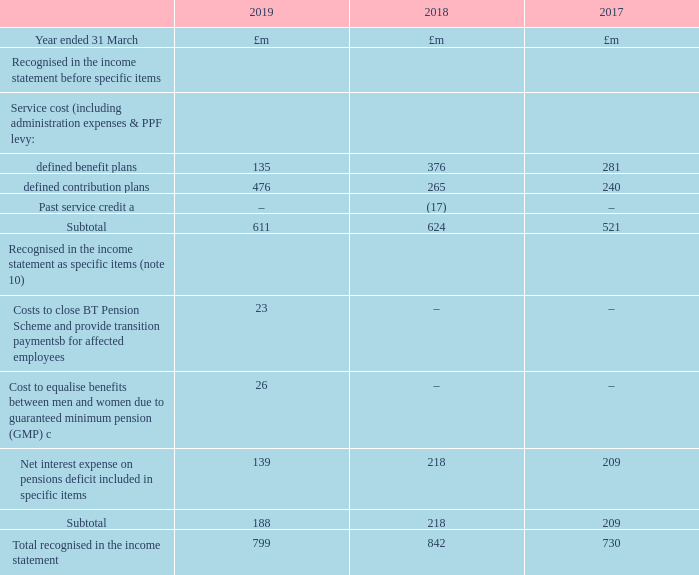Amounts in the financial statements Group income statement
The expense or income arising from all group retirement benefit arrangements recognised in the group income statement is shown below.
a Relates to the removal of future indexation obligations following changes to the benefits provided under certain pension plans operating outside the UK in 2017/18. b All employees impacted by the closure of the BTPS receive transition payments into their BTRSS pot for a period linked to the employee’s age. There was no past service cost or credit on closure due to the assumed past service benefit link as an active member being the same as that assumed for a deferred member.
c In October, a High Court judgment involving the Lloyds Banking Group’s defined benefit pension schemes was handed down, resulting in the group needing to recognise additional liability to equalise benefits between men and women due to GMPs, in common with most UK defined benefit schemes.
What was the result of the closure of the BTPS on the employees? All employees impacted by the closure of the btps receive transition payments into their btrss pot for a period linked to the employee’s age. Why was there no past service cost or credit on closure of the BTPS? There was no past service cost or credit on closure due to the assumed past service benefit link as an active member being the same as that assumed for a deferred member. What was the  Total recognised in the income statement for 2019?
Answer scale should be: million. 799. What is the change in defined benefit plans from 2019 to 2018?
Answer scale should be: million. 135-376
Answer: -241. What is the change in defined contribution plans from 2019 to 2018?
Answer scale should be: million. 476-265
Answer: 211. What is the change in Total recognised in the income statement from 2019 to 2018?
Answer scale should be: million. 799-842
Answer: -43. 